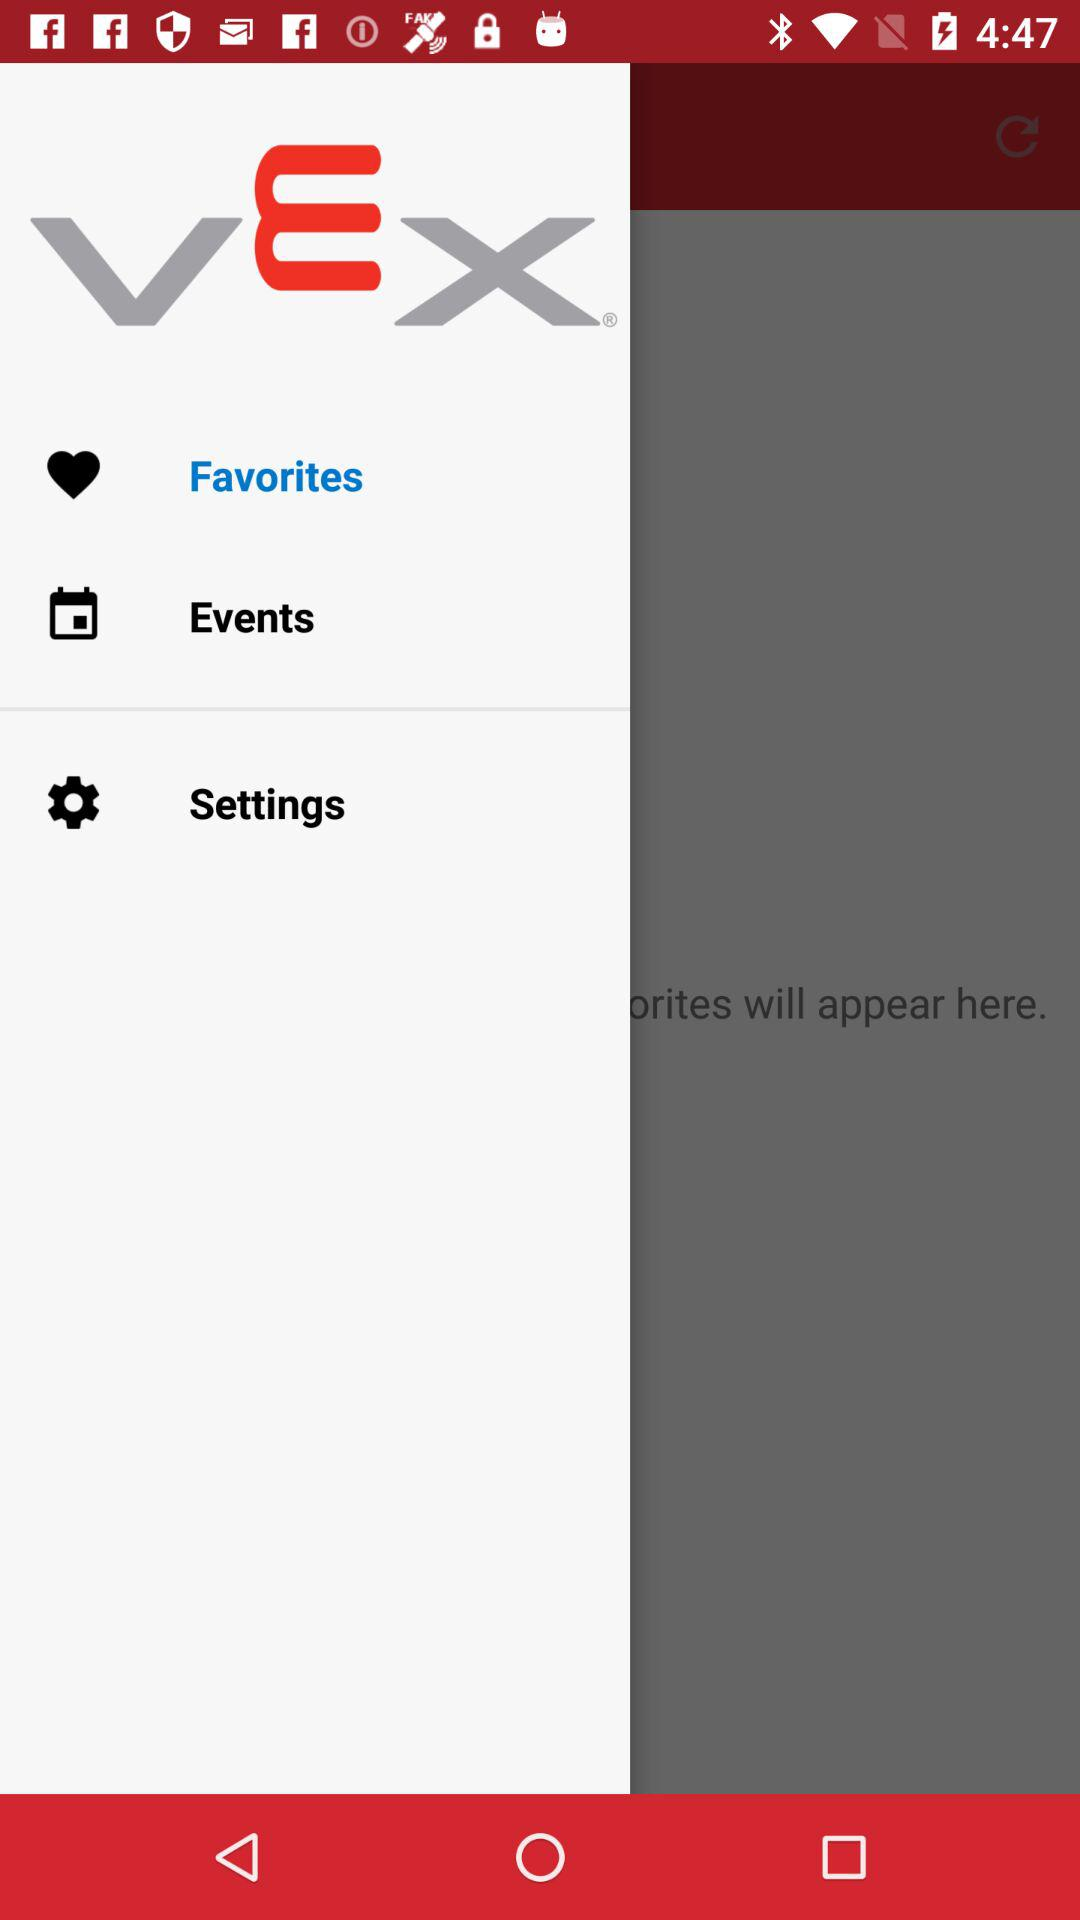Which item has been selected? The selected item is "Favorites". 